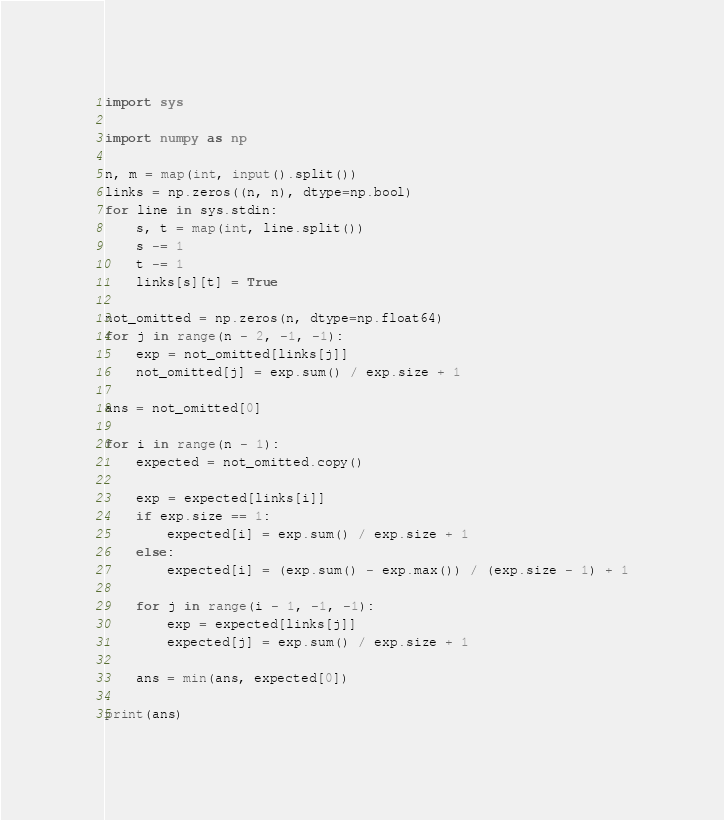<code> <loc_0><loc_0><loc_500><loc_500><_Python_>import sys

import numpy as np

n, m = map(int, input().split())
links = np.zeros((n, n), dtype=np.bool)
for line in sys.stdin:
    s, t = map(int, line.split())
    s -= 1
    t -= 1
    links[s][t] = True

not_omitted = np.zeros(n, dtype=np.float64)
for j in range(n - 2, -1, -1):
    exp = not_omitted[links[j]]
    not_omitted[j] = exp.sum() / exp.size + 1

ans = not_omitted[0]

for i in range(n - 1):
    expected = not_omitted.copy()

    exp = expected[links[i]]
    if exp.size == 1:
        expected[i] = exp.sum() / exp.size + 1
    else:
        expected[i] = (exp.sum() - exp.max()) / (exp.size - 1) + 1

    for j in range(i - 1, -1, -1):
        exp = expected[links[j]]
        expected[j] = exp.sum() / exp.size + 1

    ans = min(ans, expected[0])

print(ans)
</code> 